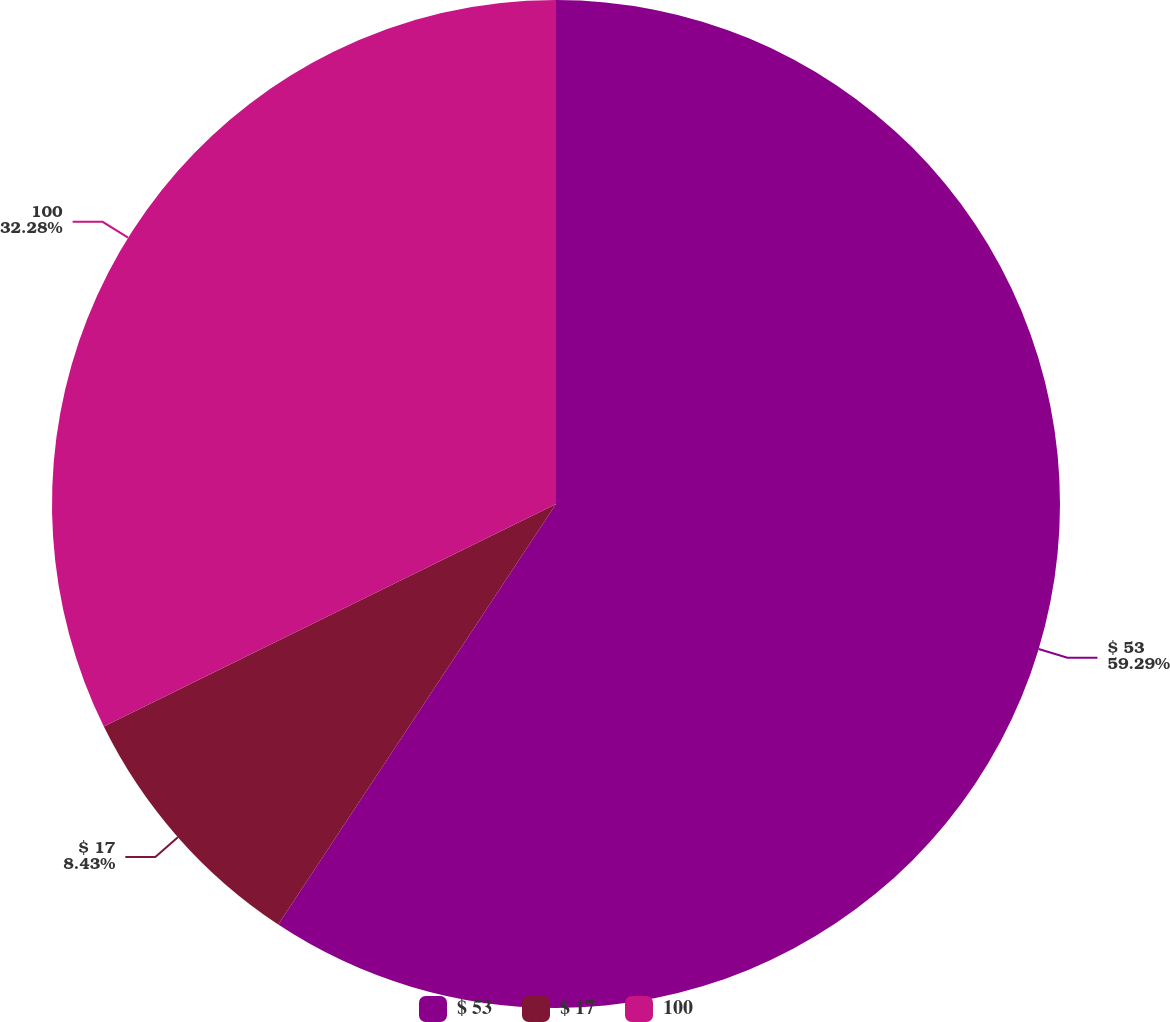<chart> <loc_0><loc_0><loc_500><loc_500><pie_chart><fcel>$ 53<fcel>$ 17<fcel>100<nl><fcel>59.29%<fcel>8.43%<fcel>32.28%<nl></chart> 